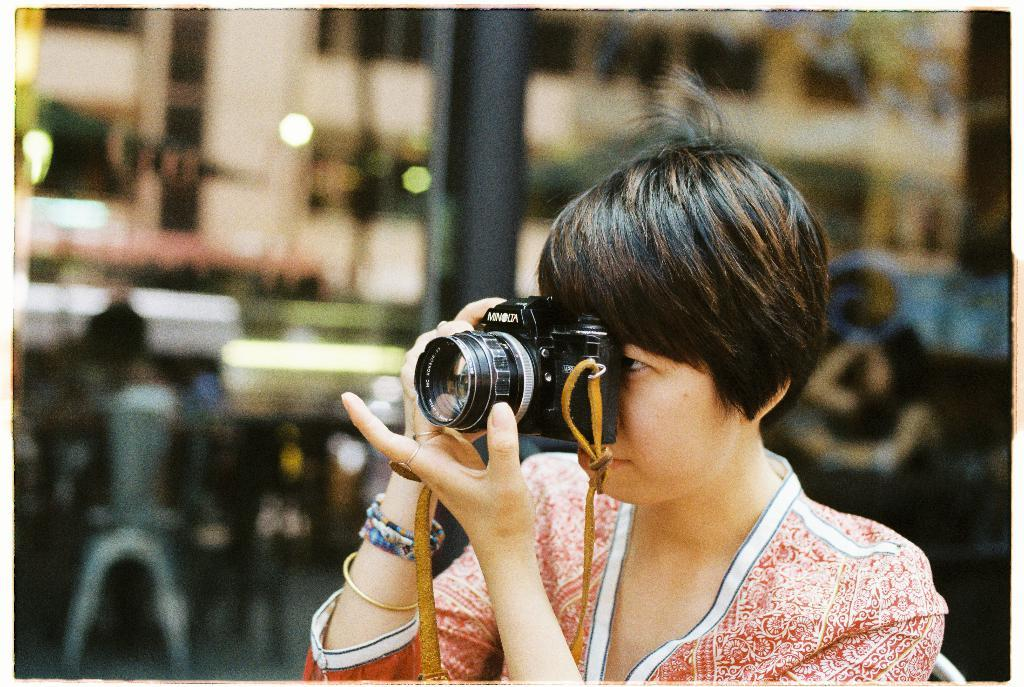What is the main subject of the image? There is a person in the image. What is the person doing in the image? The person is sitting on a chair. What object is the person holding in the image? The person is holding a camera. What type of dirt can be seen on the sofa in the image? There is no sofa present in the image, and therefore no dirt can be observed on it. 